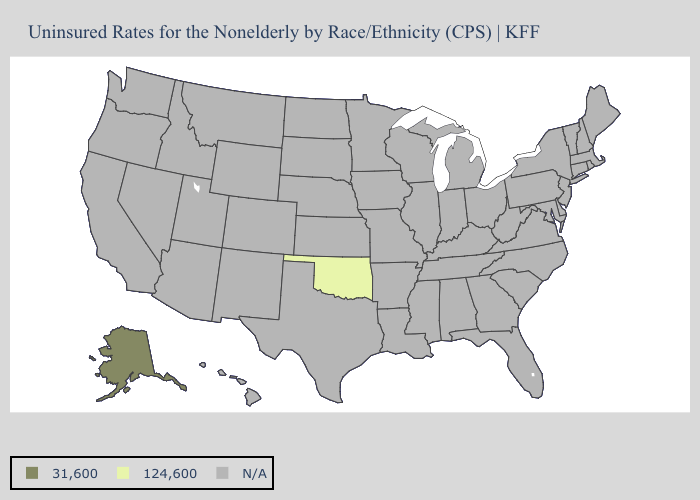Does Alaska have the lowest value in the USA?
Answer briefly. No. What is the value of Maryland?
Be succinct. N/A. What is the lowest value in the West?
Quick response, please. 31,600. Which states have the highest value in the USA?
Answer briefly. Alaska. What is the highest value in the USA?
Answer briefly. 31,600. Is the legend a continuous bar?
Write a very short answer. No. What is the value of Minnesota?
Give a very brief answer. N/A. Does Alaska have the highest value in the USA?
Give a very brief answer. Yes. 